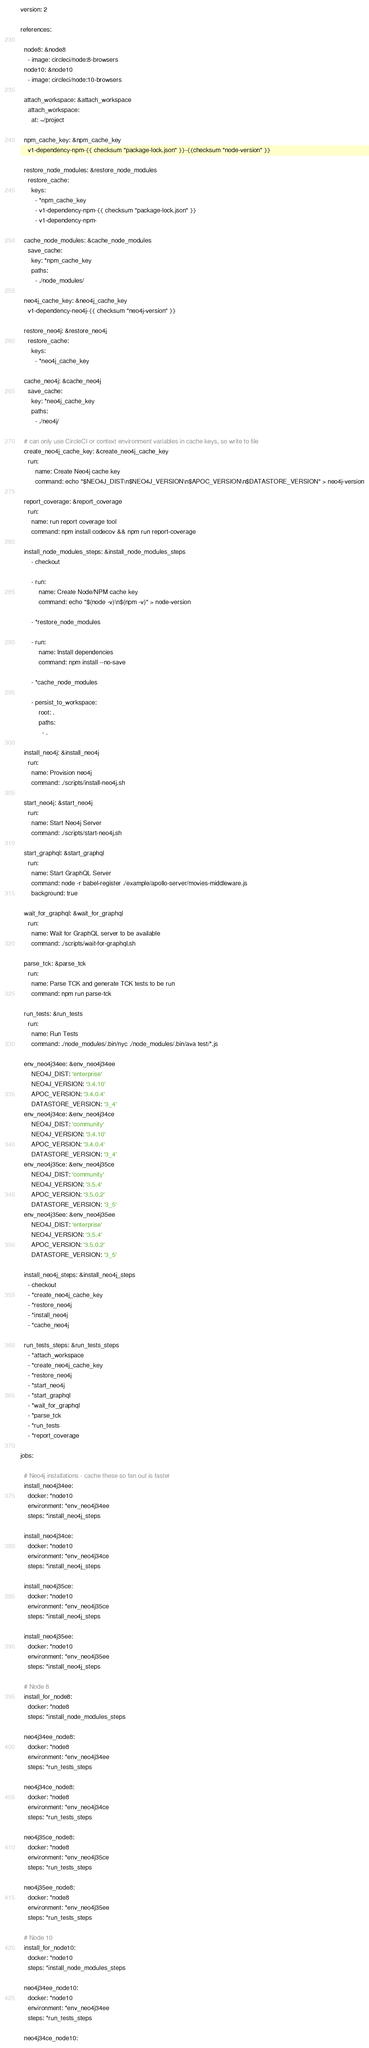<code> <loc_0><loc_0><loc_500><loc_500><_YAML_>version: 2

references:

  node8: &node8
    - image: circleci/node:8-browsers
  node10: &node10
    - image: circleci/node:10-browsers

  attach_workspace: &attach_workspace
    attach_workspace:
      at: ~/project

  npm_cache_key: &npm_cache_key
    v1-dependency-npm-{{ checksum "package-lock.json" }}-{{checksum "node-version" }}

  restore_node_modules: &restore_node_modules
    restore_cache:
      keys:
        - *npm_cache_key
        - v1-dependency-npm-{{ checksum "package-lock.json" }}
        - v1-dependency-npm-

  cache_node_modules: &cache_node_modules
    save_cache:
      key: *npm_cache_key
      paths:
        - ./node_modules/

  neo4j_cache_key: &neo4j_cache_key
    v1-dependency-neo4j-{{ checksum "neo4j-version" }}

  restore_neo4j: &restore_neo4j
    restore_cache:
      keys:
        - *neo4j_cache_key

  cache_neo4j: &cache_neo4j
    save_cache:
      key: *neo4j_cache_key
      paths:
        - ./neo4j/

  # can only use CircleCI or context environment variables in cache keys, so write to file
  create_neo4j_cache_key: &create_neo4j_cache_key
    run:
        name: Create Neo4j cache key
        command: echo "$NEO4J_DIST\n$NEO4J_VERSION\n$APOC_VERSION\n$DATASTORE_VERSION" > neo4j-version

  report_coverage: &report_coverage
    run:
      name: run report coverage tool
      command: npm install codecov && npm run report-coverage

  install_node_modules_steps: &install_node_modules_steps
      - checkout

      - run:
          name: Create Node/NPM cache key
          command: echo "$(node -v)\n$(npm -v)" > node-version

      - *restore_node_modules

      - run:
          name: Install dependencies
          command: npm install --no-save

      - *cache_node_modules

      - persist_to_workspace:
          root: .
          paths:
            - .

  install_neo4j: &install_neo4j
    run:
      name: Provision neo4j
      command: ./scripts/install-neo4j.sh

  start_neo4j: &start_neo4j
    run:
      name: Start Neo4j Server
      command: ./scripts/start-neo4j.sh

  start_graphql: &start_graphql
    run:
      name: Start GraphQL Server
      command: node -r babel-register ./example/apollo-server/movies-middleware.js
      background: true

  wait_for_graphql: &wait_for_graphql
    run:
      name: Wait for GraphQL server to be available
      command: ./scripts/wait-for-graphql.sh

  parse_tck: &parse_tck
    run:
      name: Parse TCK and generate TCK tests to be run
      command: npm run parse-tck

  run_tests: &run_tests
    run:
      name: Run Tests
      command: ./node_modules/.bin/nyc ./node_modules/.bin/ava test/*.js

  env_neo4j34ee: &env_neo4j34ee
      NEO4J_DIST: 'enterprise'
      NEO4J_VERSION: '3.4.10'
      APOC_VERSION: '3.4.0.4'
      DATASTORE_VERSION: '3_4'
  env_neo4j34ce: &env_neo4j34ce
      NEO4J_DIST: 'community'
      NEO4J_VERSION: '3.4.10'
      APOC_VERSION: '3.4.0.4'
      DATASTORE_VERSION: '3_4'
  env_neo4j35ce: &env_neo4j35ce
      NEO4J_DIST: 'community'
      NEO4J_VERSION: '3.5.4'
      APOC_VERSION: '3.5.0.2'
      DATASTORE_VERSION: '3_5'
  env_neo4j35ee: &env_neo4j35ee
      NEO4J_DIST: 'enterprise'
      NEO4J_VERSION: '3.5.4'
      APOC_VERSION: '3.5.0.2'
      DATASTORE_VERSION: '3_5'

  install_neo4j_steps: &install_neo4j_steps
    - checkout
    - *create_neo4j_cache_key
    - *restore_neo4j
    - *install_neo4j
    - *cache_neo4j

  run_tests_steps: &run_tests_steps
    - *attach_workspace
    - *create_neo4j_cache_key
    - *restore_neo4j
    - *start_neo4j
    - *start_graphql
    - *wait_for_graphql
    - *parse_tck
    - *run_tests
    - *report_coverage

jobs:

  # Neo4j installations - cache these so fan out is faster
  install_neo4j34ee:
    docker: *node10
    environment: *env_neo4j34ee
    steps: *install_neo4j_steps

  install_neo4j34ce:
    docker: *node10
    environment: *env_neo4j34ce
    steps: *install_neo4j_steps
  
  install_neo4j35ce:
    docker: *node10
    environment: *env_neo4j35ce
    steps: *install_neo4j_steps

  install_neo4j35ee:
    docker: *node10
    environment: *env_neo4j35ee
    steps: *install_neo4j_steps

  # Node 8
  install_for_node8:
    docker: *node8
    steps: *install_node_modules_steps

  neo4j34ee_node8:
    docker: *node8
    environment: *env_neo4j34ee
    steps: *run_tests_steps

  neo4j34ce_node8:
    docker: *node8
    environment: *env_neo4j34ce
    steps: *run_tests_steps

  neo4j35ce_node8:
    docker: *node8
    environment: *env_neo4j35ce
    steps: *run_tests_steps

  neo4j35ee_node8:
    docker: *node8
    environment: *env_neo4j35ee
    steps: *run_tests_steps

  # Node 10
  install_for_node10:
    docker: *node10
    steps: *install_node_modules_steps

  neo4j34ee_node10:
    docker: *node10
    environment: *env_neo4j34ee
    steps: *run_tests_steps
  
  neo4j34ce_node10:</code> 